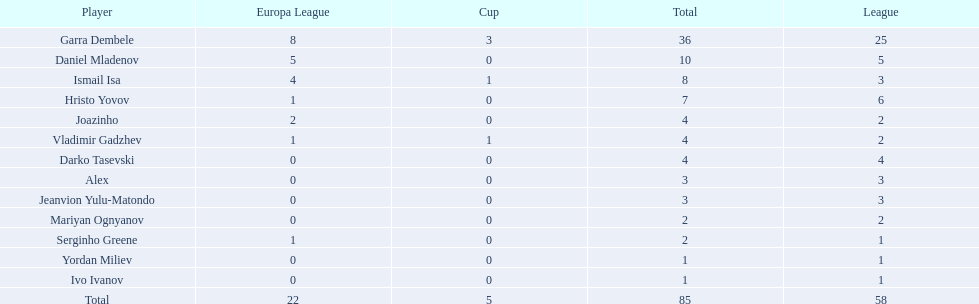Who are all of the players? Garra Dembele, Daniel Mladenov, Ismail Isa, Hristo Yovov, Joazinho, Vladimir Gadzhev, Darko Tasevski, Alex, Jeanvion Yulu-Matondo, Mariyan Ognyanov, Serginho Greene, Yordan Miliev, Ivo Ivanov. And which league is each player in? 25, 5, 3, 6, 2, 2, 4, 3, 3, 2, 1, 1, 1. Along with vladimir gadzhev and joazinho, which other player is in league 2? Mariyan Ognyanov. 